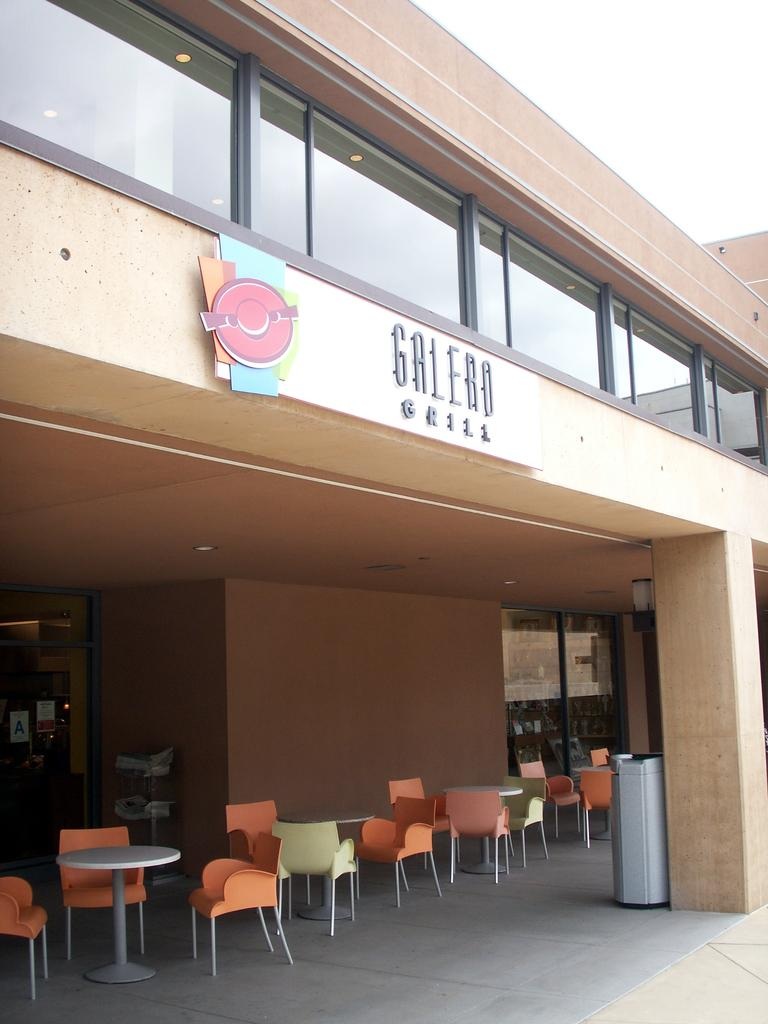What type of structure is visible in the image? There is a building in the image. What architectural features can be seen on the building? There are pillars visible in the image. What is the purpose of the bin in the image? The bin is likely for waste disposal. What type of furniture is present in the image? There are chairs and tables in the image. What type of windows are on the building? There are glass windows in the image. What hobbies do the windows in the image enjoy? Windows do not have hobbies; they are inanimate objects. What does the mouth of the building look like in the image? Buildings do not have mouths; they are inanimate structures. 